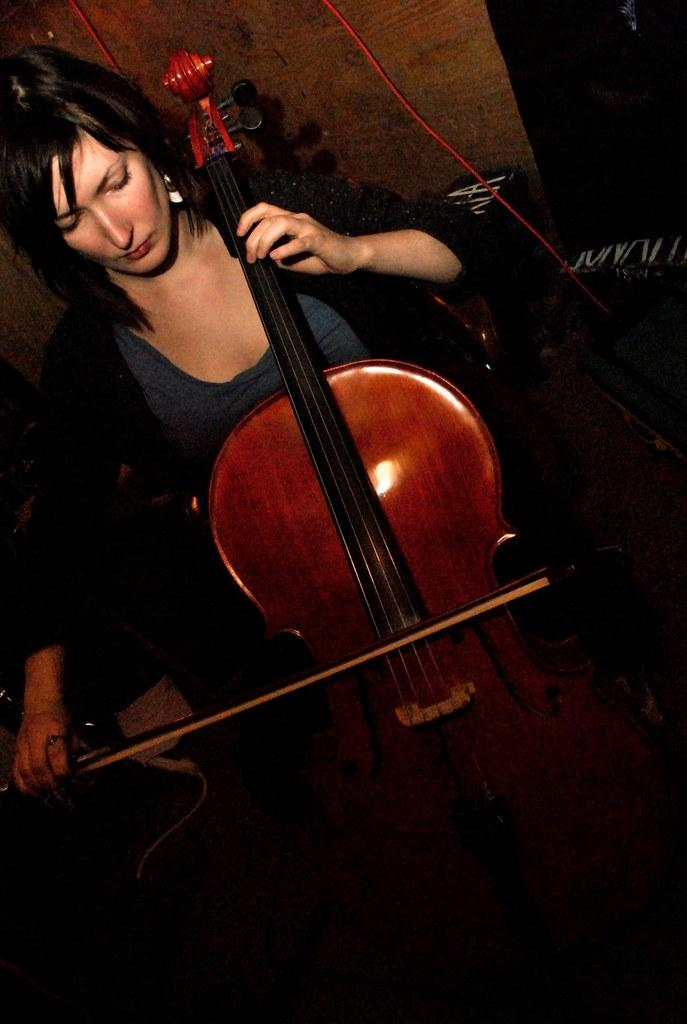What is the woman in the image doing? The woman is playing a violin. What can be seen in the background of the image? There is a wall and a red color wire in the background of the image. How many kittens are sitting on the tray in the image? There is no tray or kittens present in the image. 